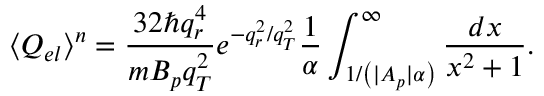<formula> <loc_0><loc_0><loc_500><loc_500>\langle Q _ { e l } \rangle ^ { n } = \frac { 3 2 \hbar { q } _ { r } ^ { 4 } } { m B _ { p } q _ { T } ^ { 2 } } e ^ { - q _ { r } ^ { 2 } / q _ { T } ^ { 2 } } \frac { 1 } { \alpha } \int _ { 1 / \left ( | A _ { p } | \alpha \right ) } ^ { \infty } { \frac { d x } { x ^ { 2 } + 1 } } .</formula> 